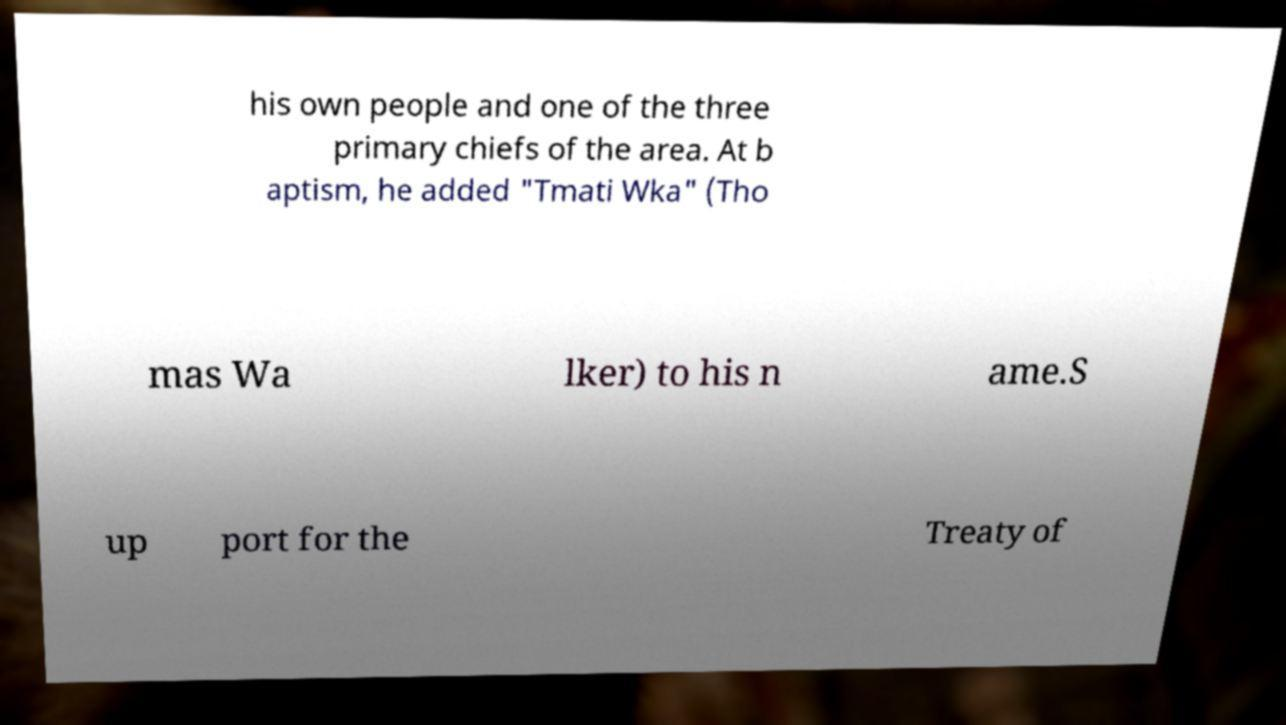There's text embedded in this image that I need extracted. Can you transcribe it verbatim? his own people and one of the three primary chiefs of the area. At b aptism, he added "Tmati Wka" (Tho mas Wa lker) to his n ame.S up port for the Treaty of 